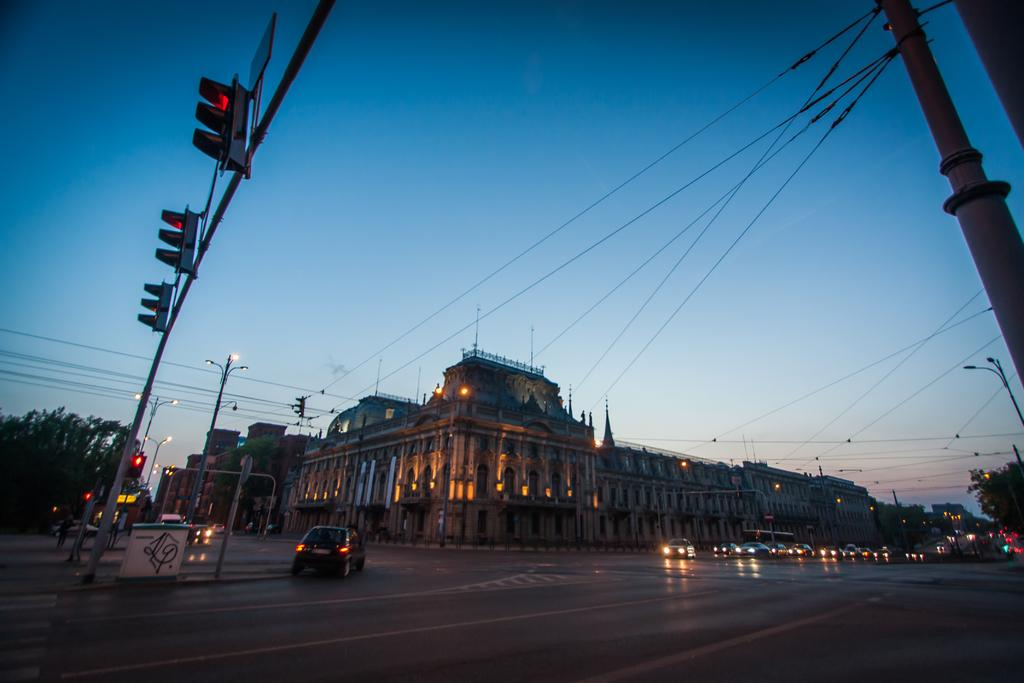What type of structures can be seen in the image? There are buildings in the image. What type of lighting is present along the road? Streetlights are present in the image. What supports the cables and wires in the image? Electric poles are visible in the image. What helps regulate traffic in the image? Traffic signals are in the image. What type of vegetation can be seen in the image? Trees are visible in the image. What type of transportation is present in the image? Cars and other vehicles are in the image. What type of illumination is visible in the image? Lights are visible in the image. What type of pathway is present in the image? There is a road in the image. What part of the natural environment is visible in the image? The sky is visible in the image. How many balls are bouncing on the road in the image? There are no balls present in the image; it features buildings, streetlights, electric poles, cables, traffic signals, trees, cars, vehicles, lights, a road, and the sky. What type of club is located near the traffic signals in the image? There is no club present in the image; it features buildings, streetlights, electric poles, cables, traffic signals, trees, cars, vehicles, lights, a road, and the sky. 